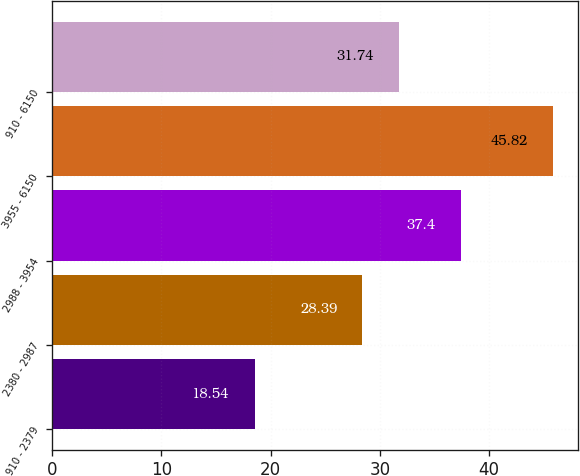Convert chart. <chart><loc_0><loc_0><loc_500><loc_500><bar_chart><fcel>910 - 2379<fcel>2380 - 2987<fcel>2988 - 3954<fcel>3955 - 6150<fcel>910 - 6150<nl><fcel>18.54<fcel>28.39<fcel>37.4<fcel>45.82<fcel>31.74<nl></chart> 